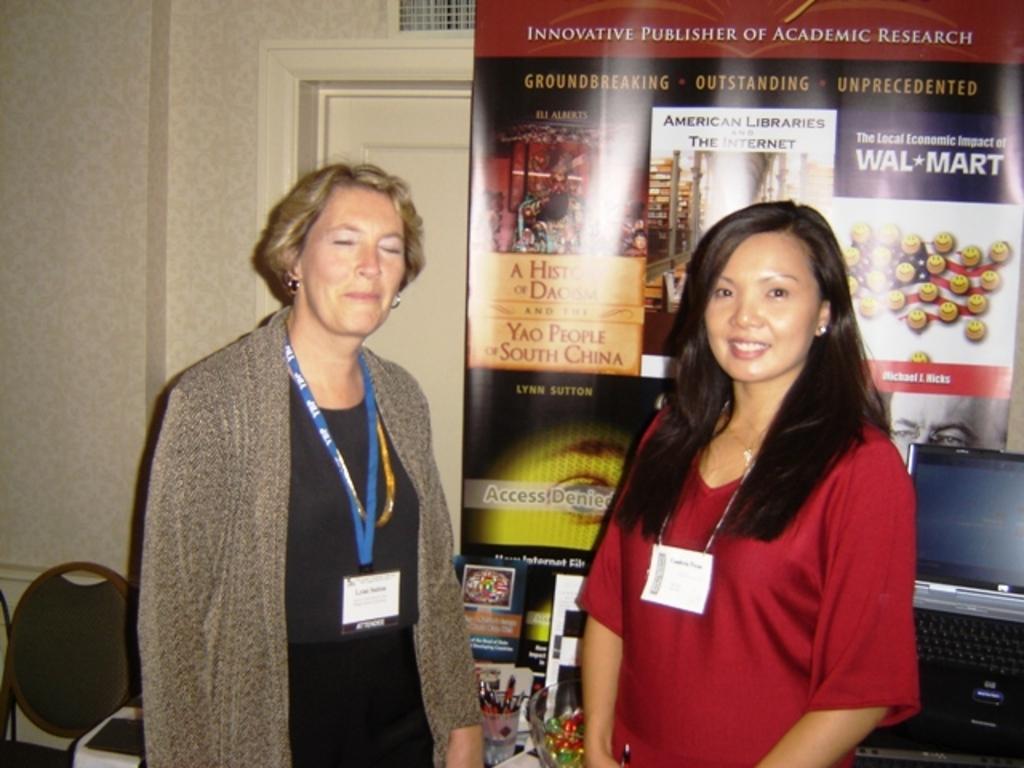Can you describe this image briefly? In this image i can see 2 women standing beside each other, and in the background i can see a banner, a door, a wall and a chair. To the right corner of the image i can see a laptop. 